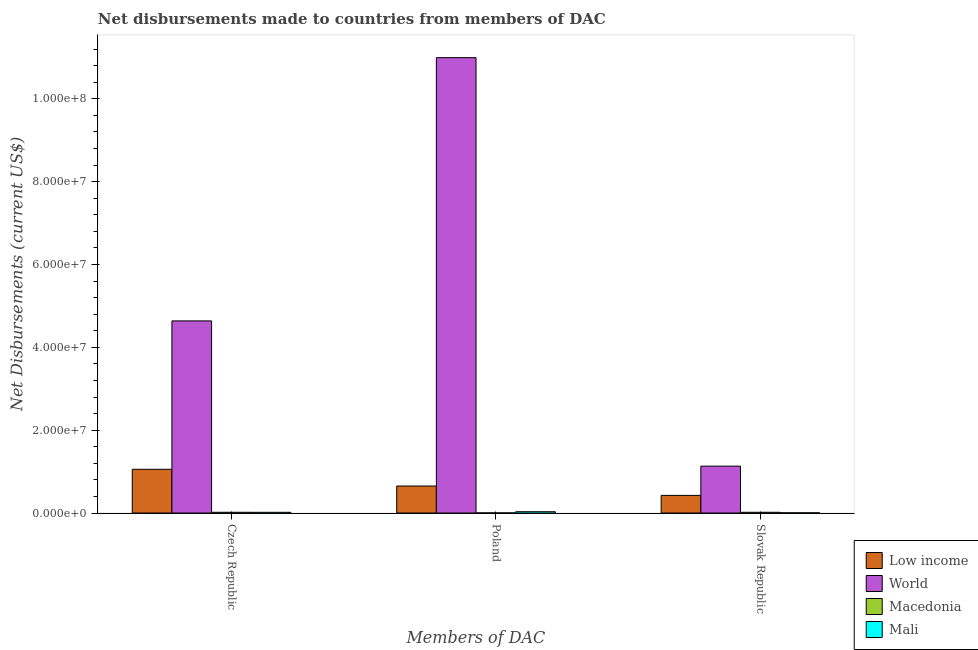How many groups of bars are there?
Ensure brevity in your answer.  3. Are the number of bars per tick equal to the number of legend labels?
Keep it short and to the point. Yes. How many bars are there on the 1st tick from the left?
Make the answer very short. 4. How many bars are there on the 3rd tick from the right?
Keep it short and to the point. 4. What is the label of the 1st group of bars from the left?
Keep it short and to the point. Czech Republic. What is the net disbursements made by slovak republic in Low income?
Offer a very short reply. 4.26e+06. Across all countries, what is the maximum net disbursements made by poland?
Your answer should be compact. 1.10e+08. Across all countries, what is the minimum net disbursements made by poland?
Ensure brevity in your answer.  3.00e+04. In which country was the net disbursements made by poland minimum?
Provide a short and direct response. Macedonia. What is the total net disbursements made by slovak republic in the graph?
Make the answer very short. 1.58e+07. What is the difference between the net disbursements made by czech republic in Macedonia and that in World?
Your answer should be compact. -4.62e+07. What is the difference between the net disbursements made by slovak republic in Mali and the net disbursements made by czech republic in Low income?
Give a very brief answer. -1.05e+07. What is the average net disbursements made by czech republic per country?
Offer a terse response. 1.43e+07. What is the difference between the net disbursements made by czech republic and net disbursements made by poland in Low income?
Make the answer very short. 4.04e+06. In how many countries, is the net disbursements made by poland greater than 44000000 US$?
Offer a terse response. 1. Is the difference between the net disbursements made by czech republic in Mali and World greater than the difference between the net disbursements made by poland in Mali and World?
Your response must be concise. Yes. What is the difference between the highest and the second highest net disbursements made by slovak republic?
Give a very brief answer. 7.06e+06. What is the difference between the highest and the lowest net disbursements made by slovak republic?
Give a very brief answer. 1.13e+07. Is the sum of the net disbursements made by poland in Mali and Macedonia greater than the maximum net disbursements made by czech republic across all countries?
Provide a short and direct response. No. What does the 1st bar from the right in Slovak Republic represents?
Ensure brevity in your answer.  Mali. Is it the case that in every country, the sum of the net disbursements made by czech republic and net disbursements made by poland is greater than the net disbursements made by slovak republic?
Make the answer very short. Yes. Are all the bars in the graph horizontal?
Give a very brief answer. No. What is the difference between two consecutive major ticks on the Y-axis?
Your response must be concise. 2.00e+07. Does the graph contain grids?
Your response must be concise. No. Where does the legend appear in the graph?
Keep it short and to the point. Bottom right. How are the legend labels stacked?
Provide a short and direct response. Vertical. What is the title of the graph?
Offer a very short reply. Net disbursements made to countries from members of DAC. What is the label or title of the X-axis?
Offer a terse response. Members of DAC. What is the label or title of the Y-axis?
Give a very brief answer. Net Disbursements (current US$). What is the Net Disbursements (current US$) of Low income in Czech Republic?
Your response must be concise. 1.06e+07. What is the Net Disbursements (current US$) of World in Czech Republic?
Offer a terse response. 4.64e+07. What is the Net Disbursements (current US$) in Low income in Poland?
Keep it short and to the point. 6.52e+06. What is the Net Disbursements (current US$) in World in Poland?
Provide a short and direct response. 1.10e+08. What is the Net Disbursements (current US$) of Low income in Slovak Republic?
Your answer should be compact. 4.26e+06. What is the Net Disbursements (current US$) in World in Slovak Republic?
Make the answer very short. 1.13e+07. What is the Net Disbursements (current US$) in Mali in Slovak Republic?
Give a very brief answer. 5.00e+04. Across all Members of DAC, what is the maximum Net Disbursements (current US$) of Low income?
Keep it short and to the point. 1.06e+07. Across all Members of DAC, what is the maximum Net Disbursements (current US$) in World?
Your answer should be very brief. 1.10e+08. Across all Members of DAC, what is the maximum Net Disbursements (current US$) of Mali?
Give a very brief answer. 3.20e+05. Across all Members of DAC, what is the minimum Net Disbursements (current US$) of Low income?
Your answer should be very brief. 4.26e+06. Across all Members of DAC, what is the minimum Net Disbursements (current US$) of World?
Ensure brevity in your answer.  1.13e+07. Across all Members of DAC, what is the minimum Net Disbursements (current US$) in Macedonia?
Provide a succinct answer. 3.00e+04. Across all Members of DAC, what is the minimum Net Disbursements (current US$) in Mali?
Provide a succinct answer. 5.00e+04. What is the total Net Disbursements (current US$) of Low income in the graph?
Keep it short and to the point. 2.13e+07. What is the total Net Disbursements (current US$) in World in the graph?
Offer a terse response. 1.68e+08. What is the total Net Disbursements (current US$) of Macedonia in the graph?
Your answer should be compact. 3.90e+05. What is the total Net Disbursements (current US$) in Mali in the graph?
Offer a very short reply. 5.40e+05. What is the difference between the Net Disbursements (current US$) in Low income in Czech Republic and that in Poland?
Offer a very short reply. 4.04e+06. What is the difference between the Net Disbursements (current US$) in World in Czech Republic and that in Poland?
Provide a succinct answer. -6.36e+07. What is the difference between the Net Disbursements (current US$) of Mali in Czech Republic and that in Poland?
Offer a very short reply. -1.50e+05. What is the difference between the Net Disbursements (current US$) of Low income in Czech Republic and that in Slovak Republic?
Offer a terse response. 6.30e+06. What is the difference between the Net Disbursements (current US$) of World in Czech Republic and that in Slovak Republic?
Offer a terse response. 3.51e+07. What is the difference between the Net Disbursements (current US$) of Low income in Poland and that in Slovak Republic?
Your answer should be compact. 2.26e+06. What is the difference between the Net Disbursements (current US$) of World in Poland and that in Slovak Republic?
Keep it short and to the point. 9.86e+07. What is the difference between the Net Disbursements (current US$) in Mali in Poland and that in Slovak Republic?
Keep it short and to the point. 2.70e+05. What is the difference between the Net Disbursements (current US$) in Low income in Czech Republic and the Net Disbursements (current US$) in World in Poland?
Ensure brevity in your answer.  -9.94e+07. What is the difference between the Net Disbursements (current US$) of Low income in Czech Republic and the Net Disbursements (current US$) of Macedonia in Poland?
Your response must be concise. 1.05e+07. What is the difference between the Net Disbursements (current US$) in Low income in Czech Republic and the Net Disbursements (current US$) in Mali in Poland?
Make the answer very short. 1.02e+07. What is the difference between the Net Disbursements (current US$) of World in Czech Republic and the Net Disbursements (current US$) of Macedonia in Poland?
Provide a short and direct response. 4.64e+07. What is the difference between the Net Disbursements (current US$) of World in Czech Republic and the Net Disbursements (current US$) of Mali in Poland?
Make the answer very short. 4.61e+07. What is the difference between the Net Disbursements (current US$) of Low income in Czech Republic and the Net Disbursements (current US$) of World in Slovak Republic?
Your response must be concise. -7.60e+05. What is the difference between the Net Disbursements (current US$) in Low income in Czech Republic and the Net Disbursements (current US$) in Macedonia in Slovak Republic?
Your response must be concise. 1.04e+07. What is the difference between the Net Disbursements (current US$) in Low income in Czech Republic and the Net Disbursements (current US$) in Mali in Slovak Republic?
Provide a short and direct response. 1.05e+07. What is the difference between the Net Disbursements (current US$) of World in Czech Republic and the Net Disbursements (current US$) of Macedonia in Slovak Republic?
Offer a terse response. 4.62e+07. What is the difference between the Net Disbursements (current US$) of World in Czech Republic and the Net Disbursements (current US$) of Mali in Slovak Republic?
Offer a very short reply. 4.63e+07. What is the difference between the Net Disbursements (current US$) in Low income in Poland and the Net Disbursements (current US$) in World in Slovak Republic?
Your answer should be compact. -4.80e+06. What is the difference between the Net Disbursements (current US$) in Low income in Poland and the Net Disbursements (current US$) in Macedonia in Slovak Republic?
Provide a succinct answer. 6.34e+06. What is the difference between the Net Disbursements (current US$) in Low income in Poland and the Net Disbursements (current US$) in Mali in Slovak Republic?
Make the answer very short. 6.47e+06. What is the difference between the Net Disbursements (current US$) of World in Poland and the Net Disbursements (current US$) of Macedonia in Slovak Republic?
Provide a short and direct response. 1.10e+08. What is the difference between the Net Disbursements (current US$) of World in Poland and the Net Disbursements (current US$) of Mali in Slovak Republic?
Make the answer very short. 1.10e+08. What is the difference between the Net Disbursements (current US$) in Macedonia in Poland and the Net Disbursements (current US$) in Mali in Slovak Republic?
Offer a terse response. -2.00e+04. What is the average Net Disbursements (current US$) of Low income per Members of DAC?
Your answer should be very brief. 7.11e+06. What is the average Net Disbursements (current US$) of World per Members of DAC?
Your response must be concise. 5.59e+07. What is the average Net Disbursements (current US$) in Mali per Members of DAC?
Your response must be concise. 1.80e+05. What is the difference between the Net Disbursements (current US$) in Low income and Net Disbursements (current US$) in World in Czech Republic?
Ensure brevity in your answer.  -3.58e+07. What is the difference between the Net Disbursements (current US$) in Low income and Net Disbursements (current US$) in Macedonia in Czech Republic?
Offer a terse response. 1.04e+07. What is the difference between the Net Disbursements (current US$) of Low income and Net Disbursements (current US$) of Mali in Czech Republic?
Keep it short and to the point. 1.04e+07. What is the difference between the Net Disbursements (current US$) of World and Net Disbursements (current US$) of Macedonia in Czech Republic?
Your answer should be very brief. 4.62e+07. What is the difference between the Net Disbursements (current US$) of World and Net Disbursements (current US$) of Mali in Czech Republic?
Ensure brevity in your answer.  4.62e+07. What is the difference between the Net Disbursements (current US$) of Macedonia and Net Disbursements (current US$) of Mali in Czech Republic?
Ensure brevity in your answer.  10000. What is the difference between the Net Disbursements (current US$) in Low income and Net Disbursements (current US$) in World in Poland?
Keep it short and to the point. -1.03e+08. What is the difference between the Net Disbursements (current US$) of Low income and Net Disbursements (current US$) of Macedonia in Poland?
Your answer should be compact. 6.49e+06. What is the difference between the Net Disbursements (current US$) of Low income and Net Disbursements (current US$) of Mali in Poland?
Offer a very short reply. 6.20e+06. What is the difference between the Net Disbursements (current US$) in World and Net Disbursements (current US$) in Macedonia in Poland?
Ensure brevity in your answer.  1.10e+08. What is the difference between the Net Disbursements (current US$) of World and Net Disbursements (current US$) of Mali in Poland?
Provide a short and direct response. 1.10e+08. What is the difference between the Net Disbursements (current US$) of Low income and Net Disbursements (current US$) of World in Slovak Republic?
Offer a terse response. -7.06e+06. What is the difference between the Net Disbursements (current US$) in Low income and Net Disbursements (current US$) in Macedonia in Slovak Republic?
Provide a short and direct response. 4.08e+06. What is the difference between the Net Disbursements (current US$) of Low income and Net Disbursements (current US$) of Mali in Slovak Republic?
Ensure brevity in your answer.  4.21e+06. What is the difference between the Net Disbursements (current US$) of World and Net Disbursements (current US$) of Macedonia in Slovak Republic?
Offer a very short reply. 1.11e+07. What is the difference between the Net Disbursements (current US$) of World and Net Disbursements (current US$) of Mali in Slovak Republic?
Make the answer very short. 1.13e+07. What is the ratio of the Net Disbursements (current US$) in Low income in Czech Republic to that in Poland?
Keep it short and to the point. 1.62. What is the ratio of the Net Disbursements (current US$) in World in Czech Republic to that in Poland?
Provide a succinct answer. 0.42. What is the ratio of the Net Disbursements (current US$) of Macedonia in Czech Republic to that in Poland?
Give a very brief answer. 6. What is the ratio of the Net Disbursements (current US$) of Mali in Czech Republic to that in Poland?
Provide a succinct answer. 0.53. What is the ratio of the Net Disbursements (current US$) of Low income in Czech Republic to that in Slovak Republic?
Give a very brief answer. 2.48. What is the ratio of the Net Disbursements (current US$) of World in Czech Republic to that in Slovak Republic?
Offer a very short reply. 4.1. What is the ratio of the Net Disbursements (current US$) in Mali in Czech Republic to that in Slovak Republic?
Your response must be concise. 3.4. What is the ratio of the Net Disbursements (current US$) in Low income in Poland to that in Slovak Republic?
Provide a short and direct response. 1.53. What is the ratio of the Net Disbursements (current US$) in World in Poland to that in Slovak Republic?
Provide a succinct answer. 9.71. What is the ratio of the Net Disbursements (current US$) in Mali in Poland to that in Slovak Republic?
Provide a short and direct response. 6.4. What is the difference between the highest and the second highest Net Disbursements (current US$) in Low income?
Your answer should be very brief. 4.04e+06. What is the difference between the highest and the second highest Net Disbursements (current US$) of World?
Give a very brief answer. 6.36e+07. What is the difference between the highest and the second highest Net Disbursements (current US$) in Macedonia?
Keep it short and to the point. 0. What is the difference between the highest and the lowest Net Disbursements (current US$) in Low income?
Offer a terse response. 6.30e+06. What is the difference between the highest and the lowest Net Disbursements (current US$) of World?
Your answer should be very brief. 9.86e+07. What is the difference between the highest and the lowest Net Disbursements (current US$) in Macedonia?
Provide a short and direct response. 1.50e+05. 